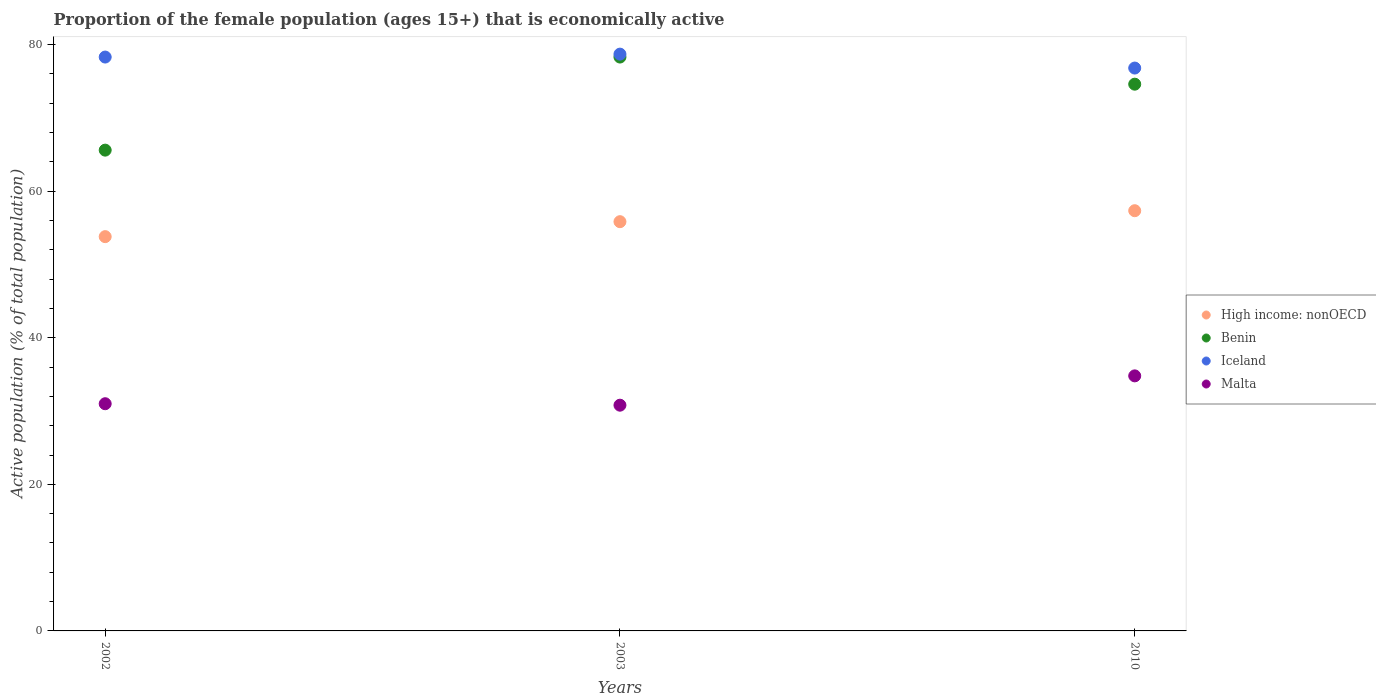How many different coloured dotlines are there?
Keep it short and to the point. 4. Is the number of dotlines equal to the number of legend labels?
Keep it short and to the point. Yes. What is the proportion of the female population that is economically active in High income: nonOECD in 2003?
Your answer should be compact. 55.84. Across all years, what is the maximum proportion of the female population that is economically active in Benin?
Offer a terse response. 78.3. Across all years, what is the minimum proportion of the female population that is economically active in High income: nonOECD?
Make the answer very short. 53.8. What is the total proportion of the female population that is economically active in High income: nonOECD in the graph?
Make the answer very short. 166.97. What is the difference between the proportion of the female population that is economically active in Benin in 2002 and that in 2003?
Give a very brief answer. -12.7. What is the difference between the proportion of the female population that is economically active in Malta in 2002 and the proportion of the female population that is economically active in Iceland in 2003?
Your answer should be compact. -47.7. What is the average proportion of the female population that is economically active in Malta per year?
Your answer should be very brief. 32.2. In the year 2010, what is the difference between the proportion of the female population that is economically active in High income: nonOECD and proportion of the female population that is economically active in Benin?
Give a very brief answer. -17.26. What is the ratio of the proportion of the female population that is economically active in Benin in 2002 to that in 2003?
Keep it short and to the point. 0.84. Is the proportion of the female population that is economically active in Iceland in 2003 less than that in 2010?
Give a very brief answer. No. Is the difference between the proportion of the female population that is economically active in High income: nonOECD in 2002 and 2003 greater than the difference between the proportion of the female population that is economically active in Benin in 2002 and 2003?
Offer a terse response. Yes. What is the difference between the highest and the second highest proportion of the female population that is economically active in Benin?
Keep it short and to the point. 3.7. What is the difference between the highest and the lowest proportion of the female population that is economically active in Iceland?
Your answer should be very brief. 1.9. Is the sum of the proportion of the female population that is economically active in Iceland in 2002 and 2010 greater than the maximum proportion of the female population that is economically active in Benin across all years?
Make the answer very short. Yes. Is it the case that in every year, the sum of the proportion of the female population that is economically active in Iceland and proportion of the female population that is economically active in Benin  is greater than the proportion of the female population that is economically active in Malta?
Provide a short and direct response. Yes. Does the proportion of the female population that is economically active in Iceland monotonically increase over the years?
Offer a terse response. No. Is the proportion of the female population that is economically active in High income: nonOECD strictly less than the proportion of the female population that is economically active in Iceland over the years?
Make the answer very short. Yes. How many years are there in the graph?
Provide a succinct answer. 3. Does the graph contain grids?
Keep it short and to the point. No. Where does the legend appear in the graph?
Make the answer very short. Center right. How many legend labels are there?
Offer a terse response. 4. What is the title of the graph?
Offer a terse response. Proportion of the female population (ages 15+) that is economically active. Does "Tonga" appear as one of the legend labels in the graph?
Ensure brevity in your answer.  No. What is the label or title of the X-axis?
Your answer should be very brief. Years. What is the label or title of the Y-axis?
Keep it short and to the point. Active population (% of total population). What is the Active population (% of total population) in High income: nonOECD in 2002?
Your answer should be compact. 53.8. What is the Active population (% of total population) in Benin in 2002?
Your response must be concise. 65.6. What is the Active population (% of total population) in Iceland in 2002?
Ensure brevity in your answer.  78.3. What is the Active population (% of total population) of Malta in 2002?
Your answer should be very brief. 31. What is the Active population (% of total population) in High income: nonOECD in 2003?
Your response must be concise. 55.84. What is the Active population (% of total population) in Benin in 2003?
Your answer should be compact. 78.3. What is the Active population (% of total population) in Iceland in 2003?
Ensure brevity in your answer.  78.7. What is the Active population (% of total population) in Malta in 2003?
Your answer should be very brief. 30.8. What is the Active population (% of total population) in High income: nonOECD in 2010?
Offer a terse response. 57.34. What is the Active population (% of total population) in Benin in 2010?
Provide a short and direct response. 74.6. What is the Active population (% of total population) of Iceland in 2010?
Offer a very short reply. 76.8. What is the Active population (% of total population) of Malta in 2010?
Provide a short and direct response. 34.8. Across all years, what is the maximum Active population (% of total population) of High income: nonOECD?
Keep it short and to the point. 57.34. Across all years, what is the maximum Active population (% of total population) in Benin?
Provide a succinct answer. 78.3. Across all years, what is the maximum Active population (% of total population) of Iceland?
Give a very brief answer. 78.7. Across all years, what is the maximum Active population (% of total population) in Malta?
Your response must be concise. 34.8. Across all years, what is the minimum Active population (% of total population) in High income: nonOECD?
Offer a very short reply. 53.8. Across all years, what is the minimum Active population (% of total population) of Benin?
Provide a succinct answer. 65.6. Across all years, what is the minimum Active population (% of total population) in Iceland?
Give a very brief answer. 76.8. Across all years, what is the minimum Active population (% of total population) of Malta?
Your answer should be very brief. 30.8. What is the total Active population (% of total population) of High income: nonOECD in the graph?
Your answer should be compact. 166.97. What is the total Active population (% of total population) of Benin in the graph?
Provide a short and direct response. 218.5. What is the total Active population (% of total population) in Iceland in the graph?
Your answer should be very brief. 233.8. What is the total Active population (% of total population) of Malta in the graph?
Provide a succinct answer. 96.6. What is the difference between the Active population (% of total population) in High income: nonOECD in 2002 and that in 2003?
Give a very brief answer. -2.04. What is the difference between the Active population (% of total population) in Benin in 2002 and that in 2003?
Keep it short and to the point. -12.7. What is the difference between the Active population (% of total population) in Malta in 2002 and that in 2003?
Your response must be concise. 0.2. What is the difference between the Active population (% of total population) of High income: nonOECD in 2002 and that in 2010?
Your response must be concise. -3.54. What is the difference between the Active population (% of total population) in Benin in 2002 and that in 2010?
Provide a succinct answer. -9. What is the difference between the Active population (% of total population) in Iceland in 2002 and that in 2010?
Keep it short and to the point. 1.5. What is the difference between the Active population (% of total population) in Malta in 2002 and that in 2010?
Provide a short and direct response. -3.8. What is the difference between the Active population (% of total population) of High income: nonOECD in 2003 and that in 2010?
Make the answer very short. -1.5. What is the difference between the Active population (% of total population) in Benin in 2003 and that in 2010?
Provide a short and direct response. 3.7. What is the difference between the Active population (% of total population) of Malta in 2003 and that in 2010?
Give a very brief answer. -4. What is the difference between the Active population (% of total population) of High income: nonOECD in 2002 and the Active population (% of total population) of Benin in 2003?
Give a very brief answer. -24.5. What is the difference between the Active population (% of total population) in High income: nonOECD in 2002 and the Active population (% of total population) in Iceland in 2003?
Your answer should be very brief. -24.9. What is the difference between the Active population (% of total population) of High income: nonOECD in 2002 and the Active population (% of total population) of Malta in 2003?
Offer a terse response. 23. What is the difference between the Active population (% of total population) of Benin in 2002 and the Active population (% of total population) of Malta in 2003?
Your answer should be compact. 34.8. What is the difference between the Active population (% of total population) in Iceland in 2002 and the Active population (% of total population) in Malta in 2003?
Offer a terse response. 47.5. What is the difference between the Active population (% of total population) in High income: nonOECD in 2002 and the Active population (% of total population) in Benin in 2010?
Give a very brief answer. -20.8. What is the difference between the Active population (% of total population) of High income: nonOECD in 2002 and the Active population (% of total population) of Iceland in 2010?
Your answer should be very brief. -23. What is the difference between the Active population (% of total population) in High income: nonOECD in 2002 and the Active population (% of total population) in Malta in 2010?
Make the answer very short. 19. What is the difference between the Active population (% of total population) in Benin in 2002 and the Active population (% of total population) in Iceland in 2010?
Your response must be concise. -11.2. What is the difference between the Active population (% of total population) in Benin in 2002 and the Active population (% of total population) in Malta in 2010?
Give a very brief answer. 30.8. What is the difference between the Active population (% of total population) in Iceland in 2002 and the Active population (% of total population) in Malta in 2010?
Provide a short and direct response. 43.5. What is the difference between the Active population (% of total population) of High income: nonOECD in 2003 and the Active population (% of total population) of Benin in 2010?
Ensure brevity in your answer.  -18.76. What is the difference between the Active population (% of total population) in High income: nonOECD in 2003 and the Active population (% of total population) in Iceland in 2010?
Offer a terse response. -20.96. What is the difference between the Active population (% of total population) of High income: nonOECD in 2003 and the Active population (% of total population) of Malta in 2010?
Make the answer very short. 21.04. What is the difference between the Active population (% of total population) of Benin in 2003 and the Active population (% of total population) of Malta in 2010?
Make the answer very short. 43.5. What is the difference between the Active population (% of total population) of Iceland in 2003 and the Active population (% of total population) of Malta in 2010?
Your answer should be very brief. 43.9. What is the average Active population (% of total population) of High income: nonOECD per year?
Make the answer very short. 55.66. What is the average Active population (% of total population) of Benin per year?
Offer a very short reply. 72.83. What is the average Active population (% of total population) of Iceland per year?
Make the answer very short. 77.93. What is the average Active population (% of total population) of Malta per year?
Make the answer very short. 32.2. In the year 2002, what is the difference between the Active population (% of total population) of High income: nonOECD and Active population (% of total population) of Benin?
Your response must be concise. -11.8. In the year 2002, what is the difference between the Active population (% of total population) of High income: nonOECD and Active population (% of total population) of Iceland?
Ensure brevity in your answer.  -24.5. In the year 2002, what is the difference between the Active population (% of total population) of High income: nonOECD and Active population (% of total population) of Malta?
Your answer should be very brief. 22.8. In the year 2002, what is the difference between the Active population (% of total population) of Benin and Active population (% of total population) of Malta?
Provide a short and direct response. 34.6. In the year 2002, what is the difference between the Active population (% of total population) in Iceland and Active population (% of total population) in Malta?
Provide a succinct answer. 47.3. In the year 2003, what is the difference between the Active population (% of total population) in High income: nonOECD and Active population (% of total population) in Benin?
Give a very brief answer. -22.46. In the year 2003, what is the difference between the Active population (% of total population) in High income: nonOECD and Active population (% of total population) in Iceland?
Your answer should be compact. -22.86. In the year 2003, what is the difference between the Active population (% of total population) of High income: nonOECD and Active population (% of total population) of Malta?
Give a very brief answer. 25.04. In the year 2003, what is the difference between the Active population (% of total population) in Benin and Active population (% of total population) in Iceland?
Provide a short and direct response. -0.4. In the year 2003, what is the difference between the Active population (% of total population) of Benin and Active population (% of total population) of Malta?
Keep it short and to the point. 47.5. In the year 2003, what is the difference between the Active population (% of total population) in Iceland and Active population (% of total population) in Malta?
Provide a succinct answer. 47.9. In the year 2010, what is the difference between the Active population (% of total population) of High income: nonOECD and Active population (% of total population) of Benin?
Keep it short and to the point. -17.26. In the year 2010, what is the difference between the Active population (% of total population) in High income: nonOECD and Active population (% of total population) in Iceland?
Your answer should be very brief. -19.46. In the year 2010, what is the difference between the Active population (% of total population) in High income: nonOECD and Active population (% of total population) in Malta?
Your answer should be compact. 22.54. In the year 2010, what is the difference between the Active population (% of total population) of Benin and Active population (% of total population) of Malta?
Your answer should be compact. 39.8. What is the ratio of the Active population (% of total population) of High income: nonOECD in 2002 to that in 2003?
Provide a short and direct response. 0.96. What is the ratio of the Active population (% of total population) in Benin in 2002 to that in 2003?
Provide a short and direct response. 0.84. What is the ratio of the Active population (% of total population) of High income: nonOECD in 2002 to that in 2010?
Provide a short and direct response. 0.94. What is the ratio of the Active population (% of total population) in Benin in 2002 to that in 2010?
Ensure brevity in your answer.  0.88. What is the ratio of the Active population (% of total population) in Iceland in 2002 to that in 2010?
Make the answer very short. 1.02. What is the ratio of the Active population (% of total population) of Malta in 2002 to that in 2010?
Ensure brevity in your answer.  0.89. What is the ratio of the Active population (% of total population) in High income: nonOECD in 2003 to that in 2010?
Your response must be concise. 0.97. What is the ratio of the Active population (% of total population) of Benin in 2003 to that in 2010?
Your response must be concise. 1.05. What is the ratio of the Active population (% of total population) in Iceland in 2003 to that in 2010?
Keep it short and to the point. 1.02. What is the ratio of the Active population (% of total population) of Malta in 2003 to that in 2010?
Ensure brevity in your answer.  0.89. What is the difference between the highest and the second highest Active population (% of total population) in High income: nonOECD?
Offer a very short reply. 1.5. What is the difference between the highest and the second highest Active population (% of total population) in Malta?
Keep it short and to the point. 3.8. What is the difference between the highest and the lowest Active population (% of total population) of High income: nonOECD?
Give a very brief answer. 3.54. What is the difference between the highest and the lowest Active population (% of total population) in Benin?
Offer a very short reply. 12.7. What is the difference between the highest and the lowest Active population (% of total population) in Iceland?
Your answer should be compact. 1.9. What is the difference between the highest and the lowest Active population (% of total population) in Malta?
Your answer should be very brief. 4. 